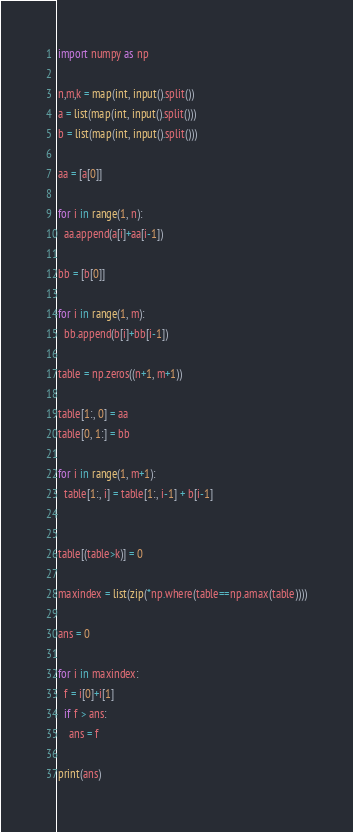Convert code to text. <code><loc_0><loc_0><loc_500><loc_500><_Python_>import numpy as np

n,m,k = map(int, input().split())
a = list(map(int, input().split()))
b = list(map(int, input().split()))

aa = [a[0]]

for i in range(1, n):
  aa.append(a[i]+aa[i-1])
  
bb = [b[0]]

for i in range(1, m):
  bb.append(b[i]+bb[i-1])
  
table = np.zeros((n+1, m+1))

table[1:, 0] = aa
table[0, 1:] = bb

for i in range(1, m+1):
  table[1:, i] = table[1:, i-1] + b[i-1]
  

table[(table>k)] = 0

maxindex = list(zip(*np.where(table==np.amax(table))))

ans = 0

for i in maxindex:
  f = i[0]+i[1]
  if f > ans:
    ans = f

print(ans)</code> 